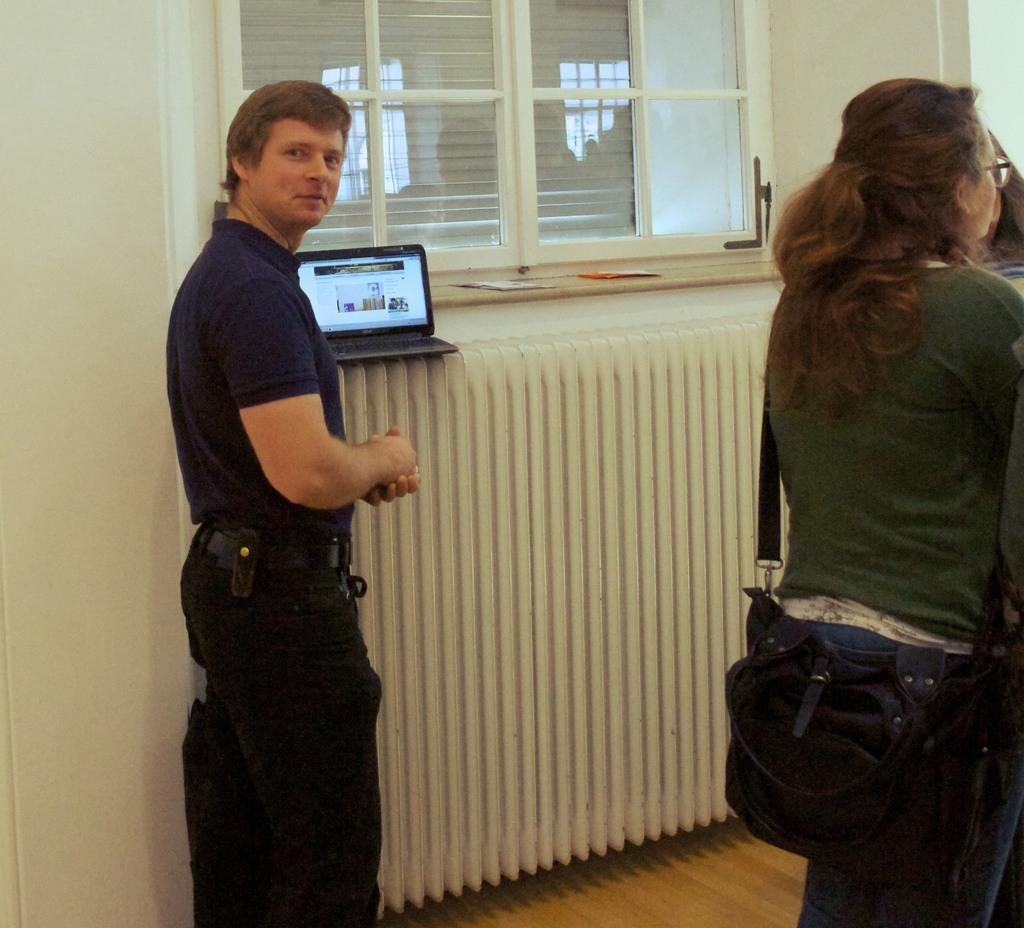Who can be seen in the image? There are people in the image. What is the woman wearing in the image? The woman is wearing a bag in the image. What electronic device is visible beside a person? There is a laptop beside a person in the image. Where are papers and a laptop located in the image? Papers and a laptop are in front of a window in the image. How many test tickets are visible in the image? There is no mention of tests or tickets in the image; it features people, a woman with a bag, a laptop, papers, and a window. 